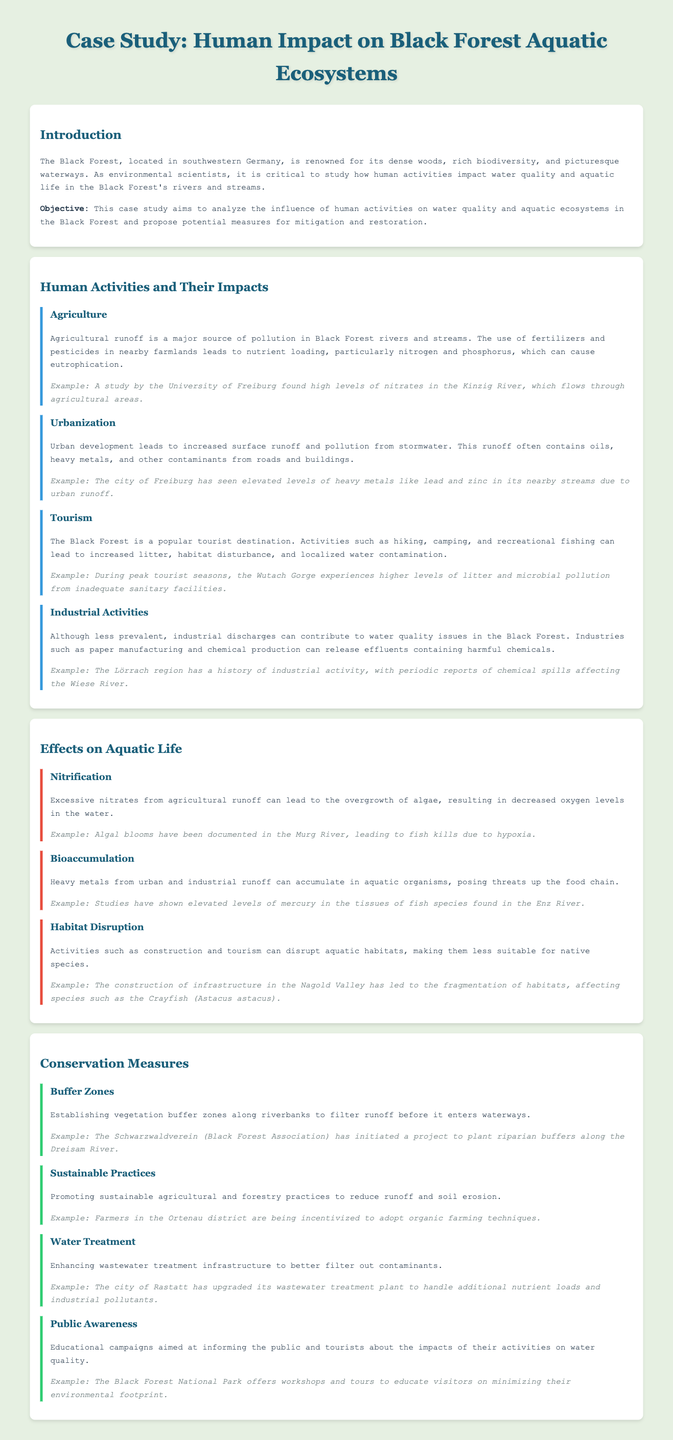What human activity is a major source of pollution in Black Forest rivers? The document lists agriculture, specifically agricultural runoff, as a major source of pollution due to the use of fertilizers and pesticides.
Answer: Agriculture What type of pollution is associated with urban development? The document states that urbanization leads to pollution from stormwater, which contains oils, heavy metals, and other contaminants.
Answer: Stormwater pollution Which river has high levels of nitrates due to agricultural runoff? The document mentions that the Kinzig River has high levels of nitrates attributable to nearby agricultural areas.
Answer: Kinzig River What phenomenon occurs due to excessive nitrates and leads to fish kills? The document explains that excessive nitrates can lead to algal blooms, which decrease oxygen levels in the water, causing hypoxia and fish kills.
Answer: Algal blooms What conservation measure involves planting vegetation along riverbanks? The document refers to establishing buffer zones as a conservation measure to filter runoff before it enters waterways.
Answer: Buffer zones What industry has a history of contributing to water quality issues in the Black Forest? The document indicates that paper manufacturing and chemical production are industries that can release harmful effluents into the waterways.
Answer: Paper manufacturing Which river has documented algal blooms leading to fish kills? The document states that algal blooms have been recorded in the Murg River, affecting fish populations.
Answer: Murg River What is one way to promote sustainable agricultural practices mentioned in the document? The document notes that farmers in the Ortenau district are incentivized to adopt organic farming techniques as a means to promote sustainability.
Answer: Organic farming techniques What educational campaign does the Black Forest National Park offer to tourists? The document mentions that the park offers workshops and tours to educate visitors on minimizing their environmental footprint.
Answer: Workshops and tours 